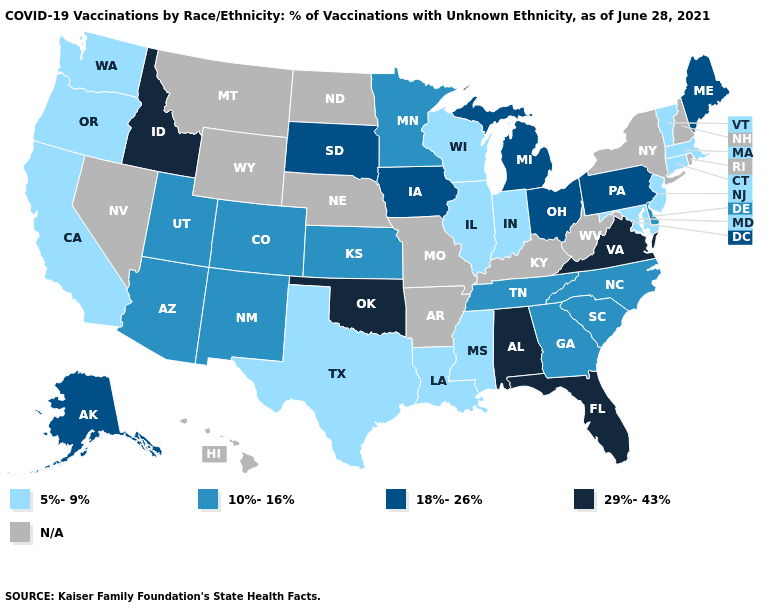Name the states that have a value in the range 18%-26%?
Give a very brief answer. Alaska, Iowa, Maine, Michigan, Ohio, Pennsylvania, South Dakota. What is the lowest value in the USA?
Keep it brief. 5%-9%. Does Arizona have the lowest value in the West?
Be succinct. No. Is the legend a continuous bar?
Write a very short answer. No. What is the value of Iowa?
Concise answer only. 18%-26%. Which states have the highest value in the USA?
Keep it brief. Alabama, Florida, Idaho, Oklahoma, Virginia. How many symbols are there in the legend?
Be succinct. 5. How many symbols are there in the legend?
Short answer required. 5. What is the highest value in the South ?
Concise answer only. 29%-43%. Which states have the lowest value in the USA?
Quick response, please. California, Connecticut, Illinois, Indiana, Louisiana, Maryland, Massachusetts, Mississippi, New Jersey, Oregon, Texas, Vermont, Washington, Wisconsin. What is the value of Hawaii?
Write a very short answer. N/A. Name the states that have a value in the range 29%-43%?
Quick response, please. Alabama, Florida, Idaho, Oklahoma, Virginia. What is the highest value in the MidWest ?
Give a very brief answer. 18%-26%. Name the states that have a value in the range 18%-26%?
Give a very brief answer. Alaska, Iowa, Maine, Michigan, Ohio, Pennsylvania, South Dakota. 